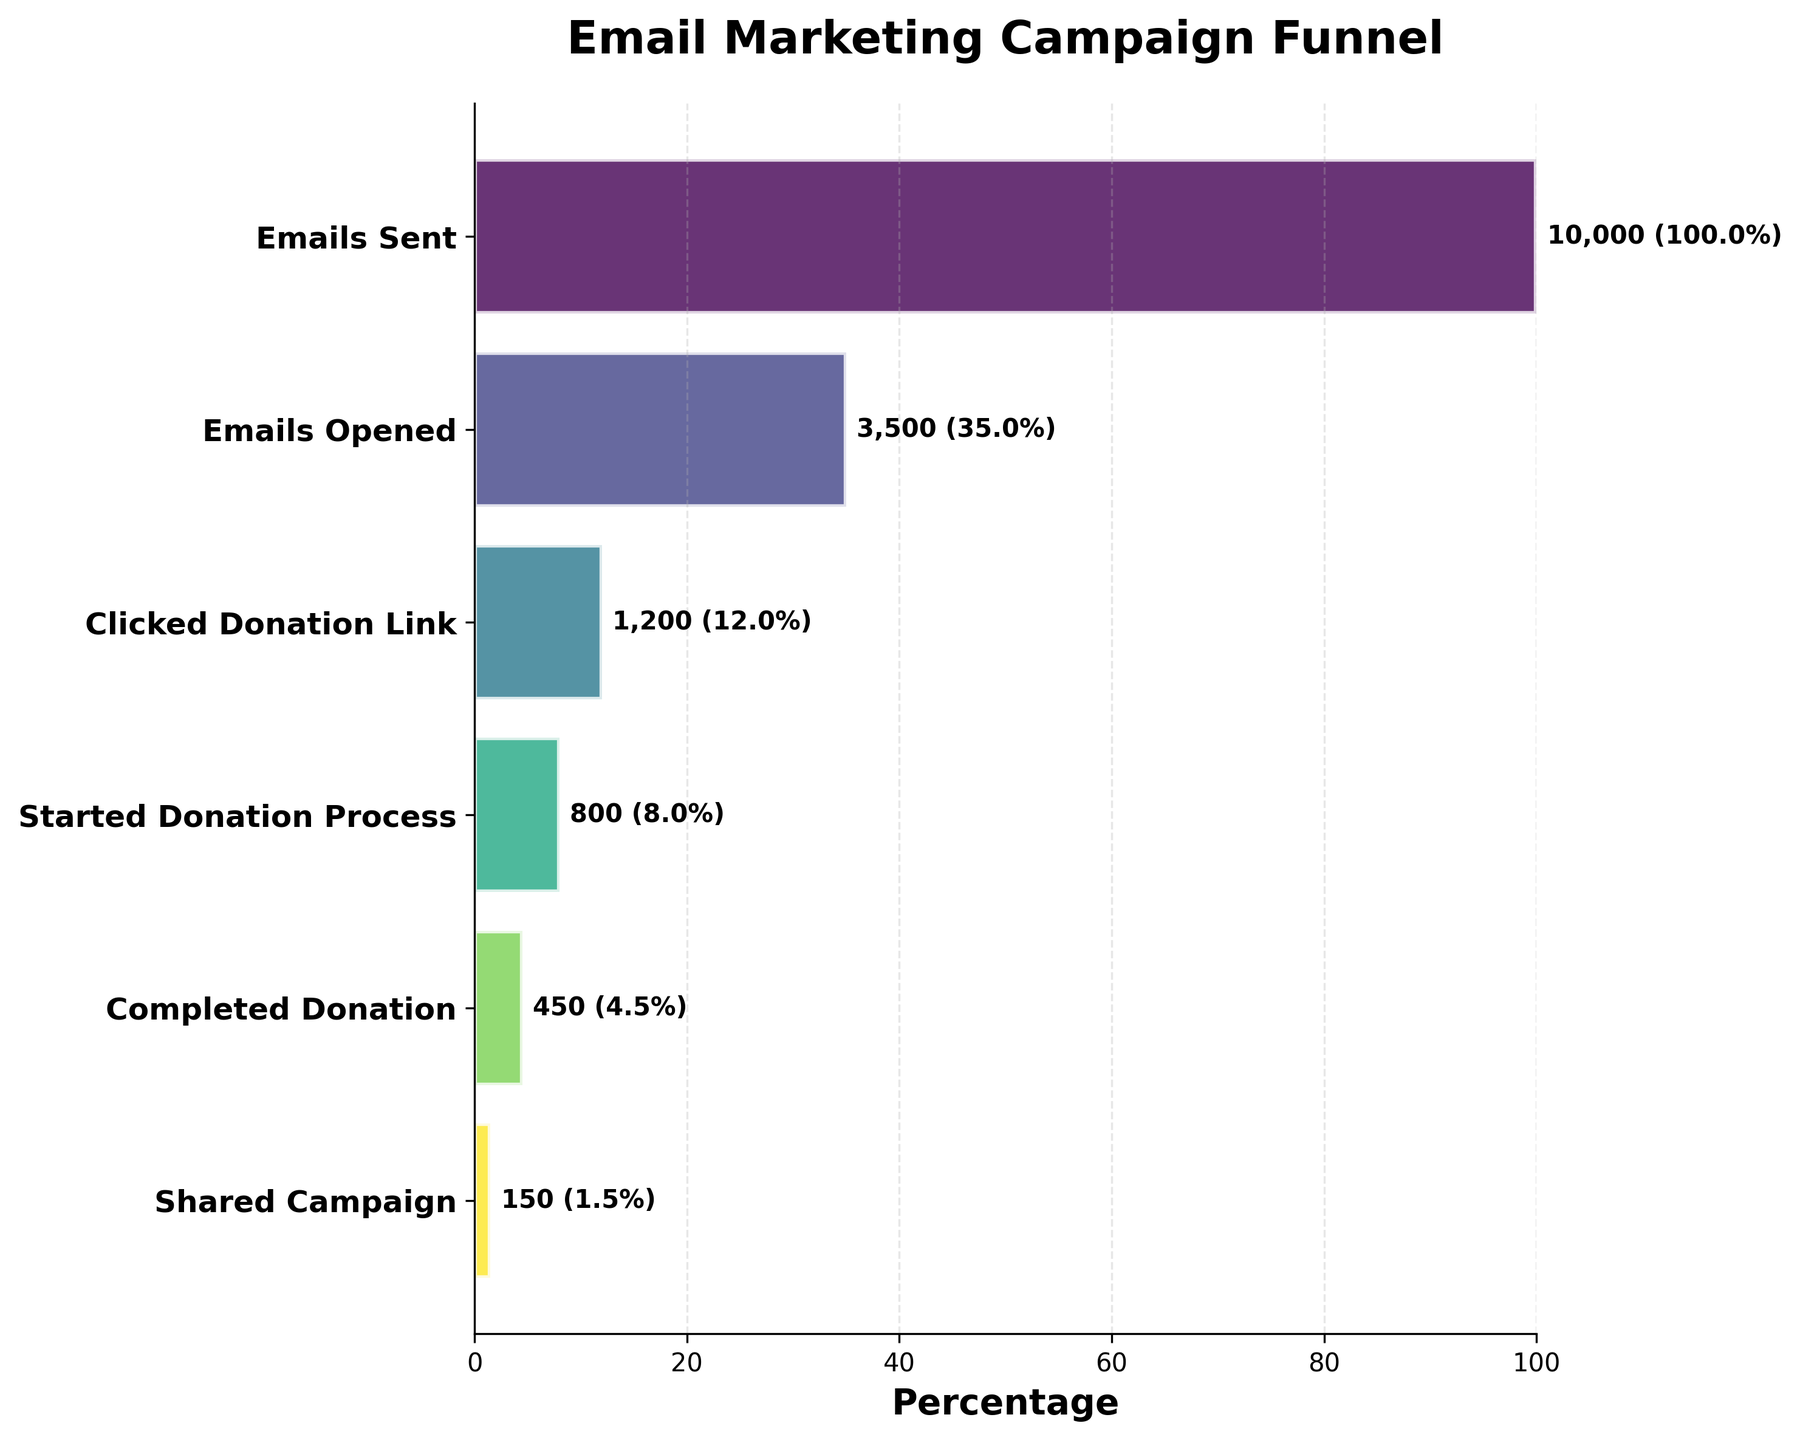what is the title of the chart? The title of the chart is displayed at the top of the figure, usually in larger and bolder font. Here, the title is centered and reads "Email Marketing Campaign Funnel".
Answer: Email Marketing Campaign Funnel What percentage of recipients completed the donation process? The percentage completion is shown by the horizontal bar corresponding to "Completed Donation"; it is also labeled with a value. It calculates the percentage as (450 / 10000) * 100%.
Answer: 4.5% What's the total number of recipients shared the campaign? The value is shown next to the horizontal bar labeled "Shared Campaign". This is the last stage in the funnel, making it easy to identify.
Answer: 150 How many more recipients opened the emails compared to those who started the donation process? To find this, subtract the number of recipients who started the donation process (800) from the number who opened the emails (3500). This is a simple subtraction problem.
Answer: 2700 Which stage had the biggest drop in number of participants? By examining the length of the bars and the values, identify the two stages with the greatest difference in the number of recipients. The biggest drop is from "Emails Opened" (3500) to "Clicked Donation Link" (1200).
Answer: From "Emails Opened" to "Clicked Donation Link" What is the completion percentage from clicking on the donation link to sharing the campaign? To find the percentage, use the formula: (Number sharing/Number clicked link) * 100%. Hence (150 / 1200) * 100% is the calculation.
Answer: 12.5% Compare the number of recipients who completed the donation to those who started it. Which is larger and by how much? Look at the values for "Completed Donation" (450) and "Started Donation Process" (800). Subtract to find the difference, and identify the larger group.
Answer: Started Donation Process is larger by 350 What percentage of the recipients started the donation process after clicking the donation link? Calculate the percentage as the ratio of "Started Donation Process" to "Clicked Donation Link", then multiplying by 100%. (800 / 1200) * 100%.
Answer: 66.7% How does the percentage of email openers compare to those who clicked on the donation link? Compare "Emails Opened" (3500) to "Clicked Donation Link" (1200), by dividing the latter by the former and multiplying by 100%. (1200 / 3500) * 100%.
Answer: 34.3% List the stages in order from highest to lowest number of recipients. Read the values plotted against each stage and arrange them in descending order from the funnel chart.
Answer: Emails Sent, Emails Opened, Clicked Donation Link, Started Donation Process, Completed Donation, Shared Campaign 